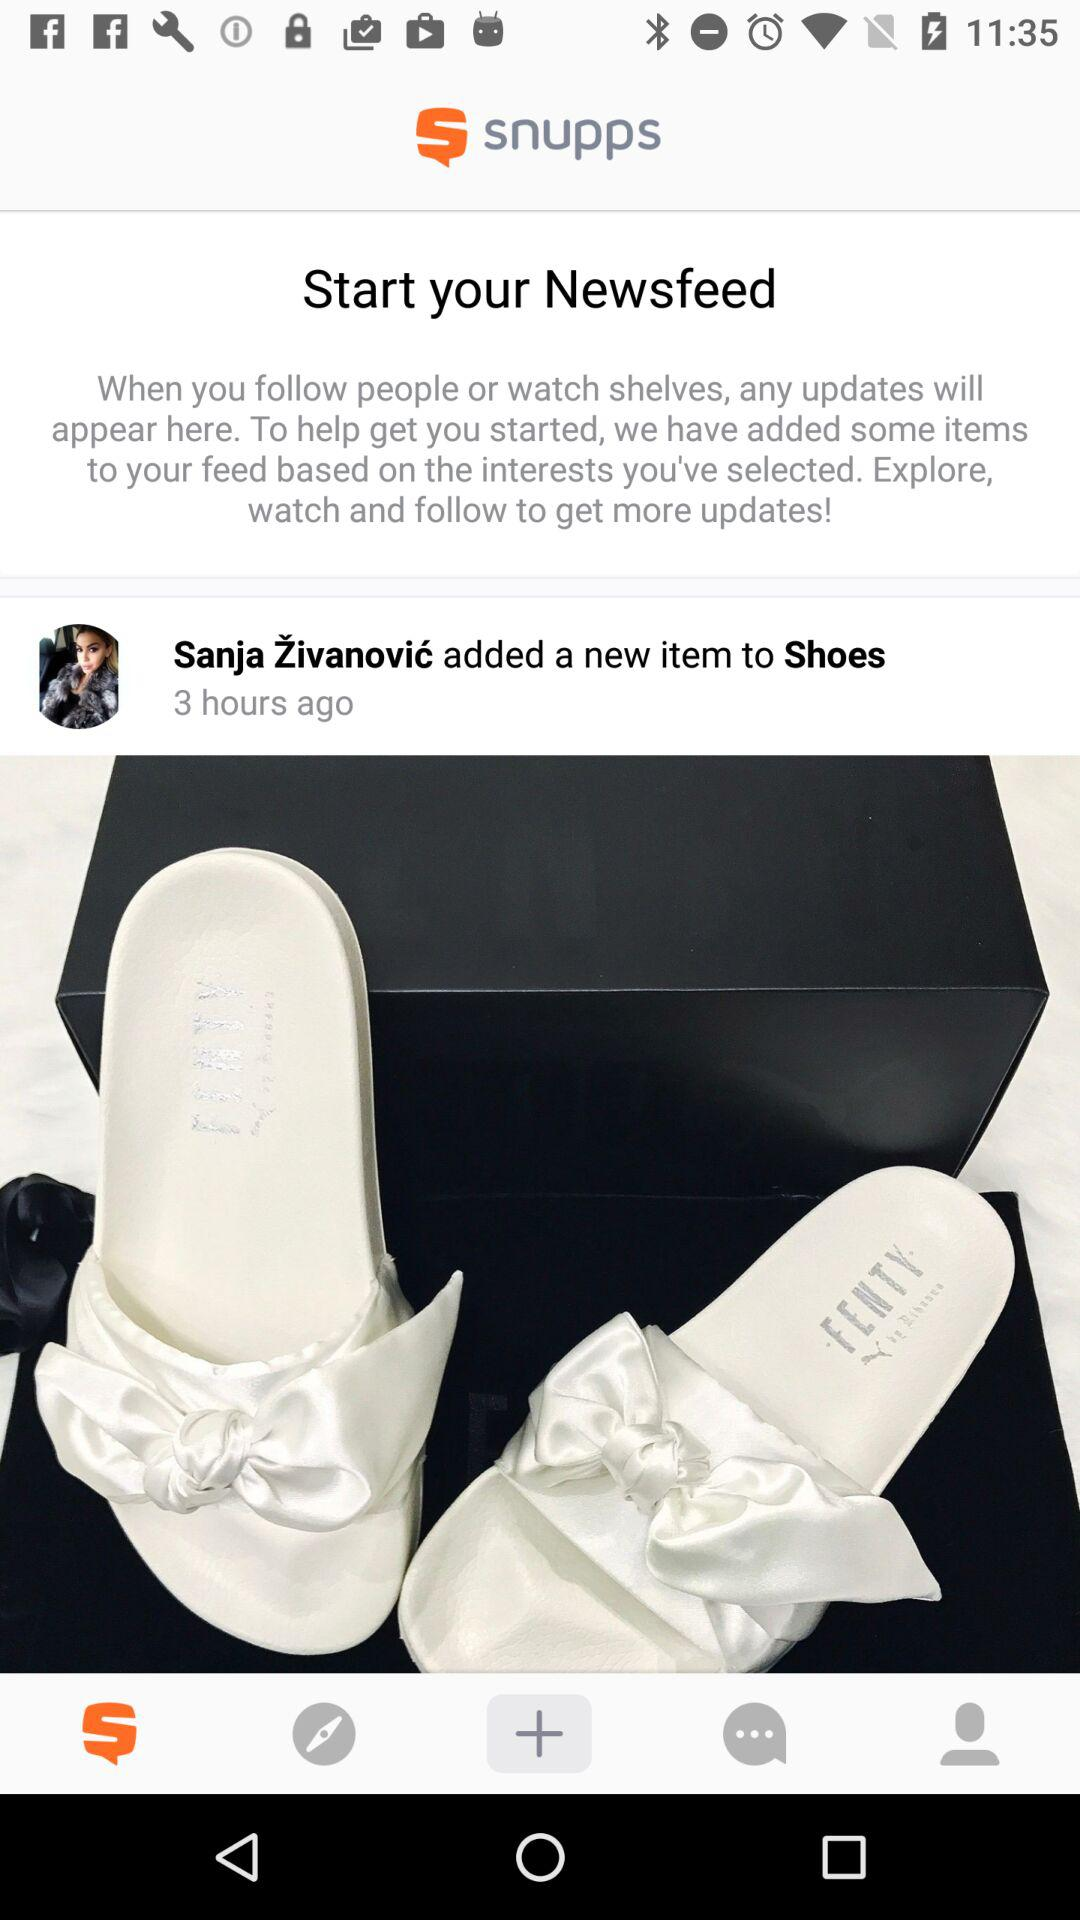How many items are there in the Newsfeed?
Answer the question using a single word or phrase. 1 